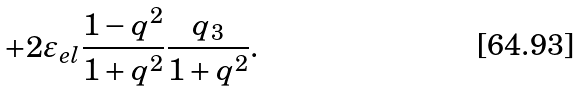Convert formula to latex. <formula><loc_0><loc_0><loc_500><loc_500>+ 2 \varepsilon _ { e l } \frac { 1 - { q ^ { 2 } } } { 1 + { q ^ { 2 } } } \frac { q _ { 3 } } { 1 + { q ^ { 2 } } } .</formula> 